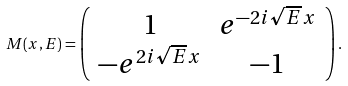<formula> <loc_0><loc_0><loc_500><loc_500>M ( x , E ) = \left ( \begin{array} { c c } 1 & e ^ { - 2 i \sqrt { E } x } \\ - e ^ { 2 i \sqrt { E } x } & - 1 \end{array} \right ) .</formula> 